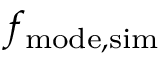Convert formula to latex. <formula><loc_0><loc_0><loc_500><loc_500>f _ { m o d e , s i m }</formula> 